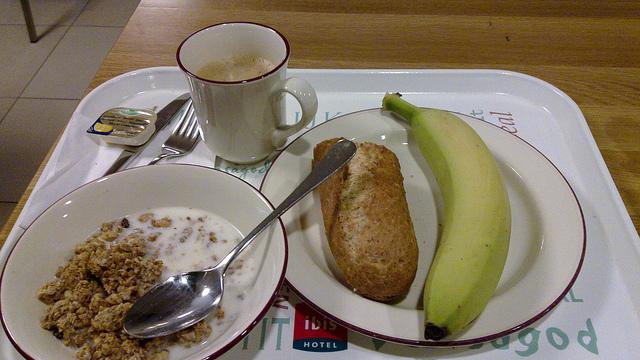How many foods are uneaten?
Be succinct. 2. Is there a bowl of cereal on the tray?
Answer briefly. Yes. Did the person use butter in this meal?
Be succinct. No. 